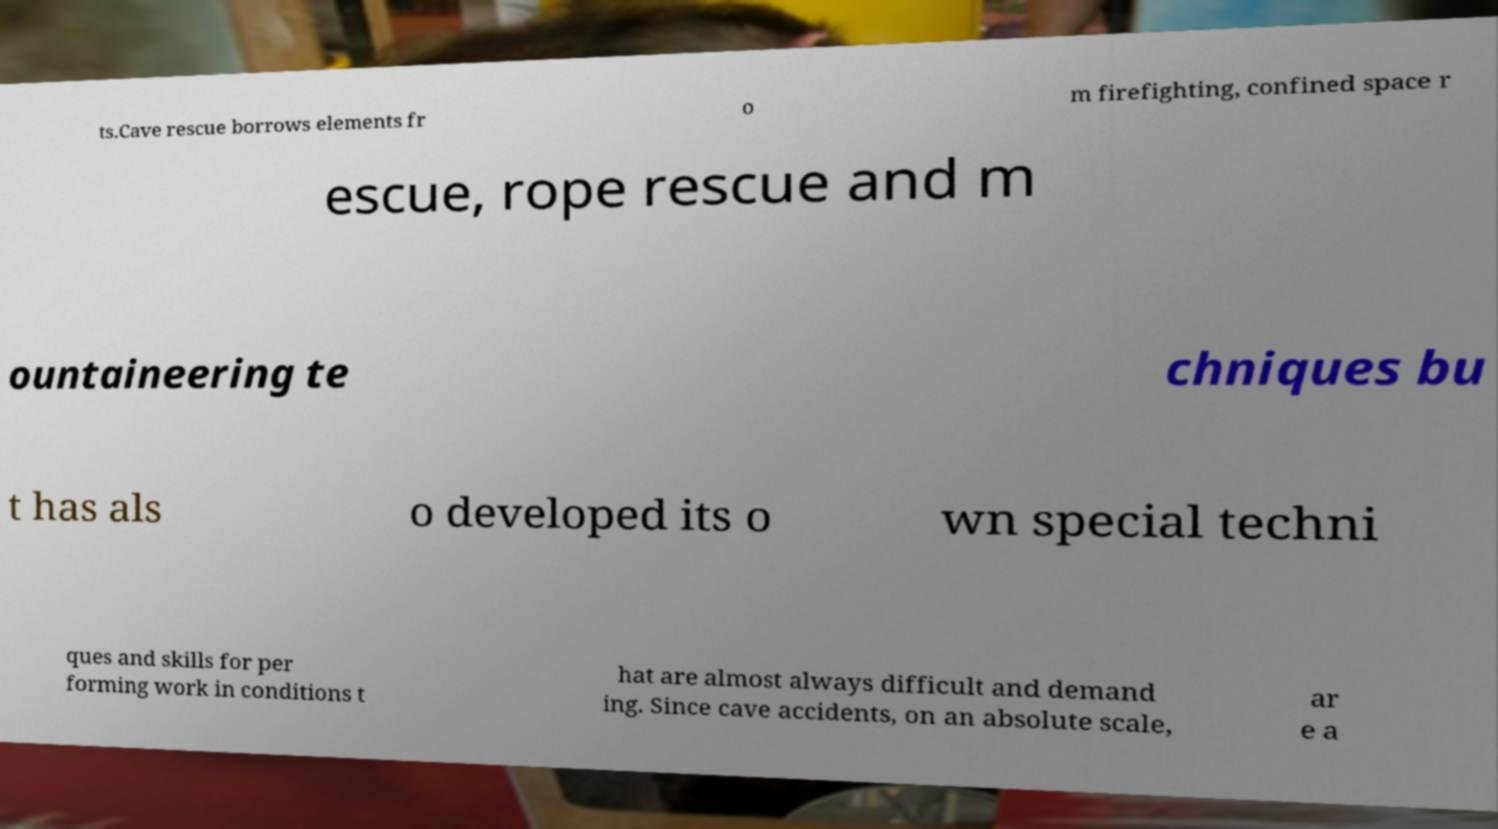What messages or text are displayed in this image? I need them in a readable, typed format. ts.Cave rescue borrows elements fr o m firefighting, confined space r escue, rope rescue and m ountaineering te chniques bu t has als o developed its o wn special techni ques and skills for per forming work in conditions t hat are almost always difficult and demand ing. Since cave accidents, on an absolute scale, ar e a 